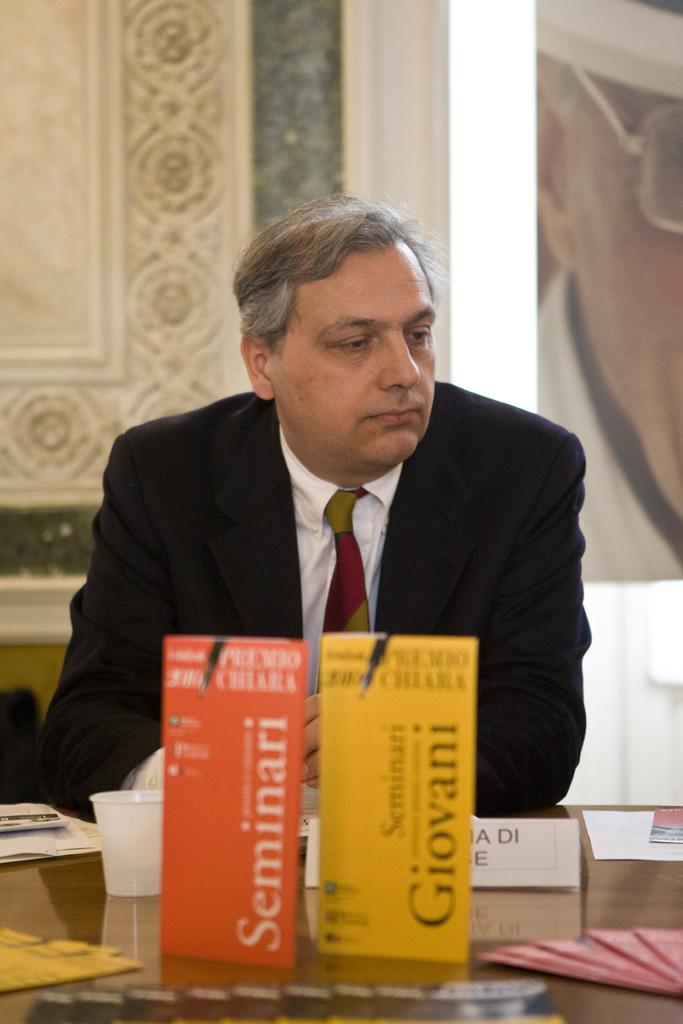<image>
Offer a succinct explanation of the picture presented. A man sits behind pamplets for Seminari and Giovani. 